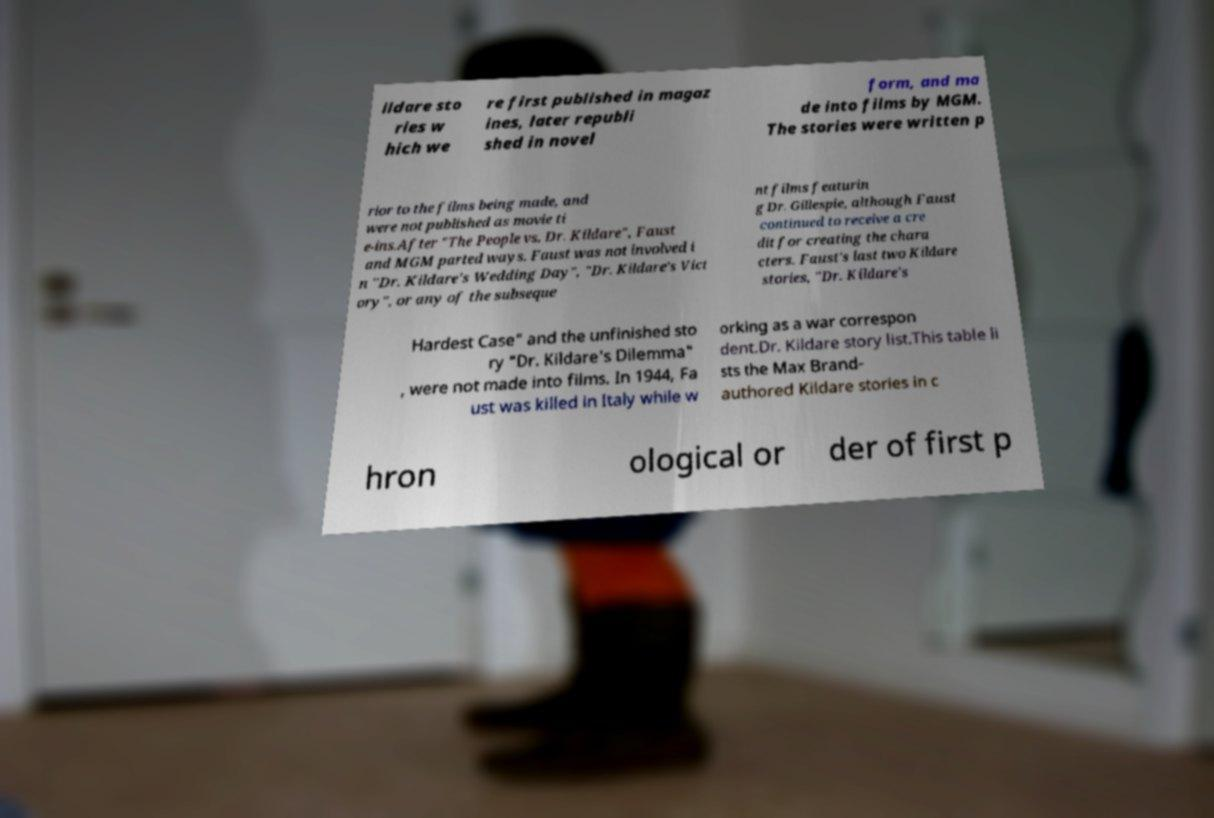Could you assist in decoding the text presented in this image and type it out clearly? ildare sto ries w hich we re first published in magaz ines, later republi shed in novel form, and ma de into films by MGM. The stories were written p rior to the films being made, and were not published as movie ti e-ins.After "The People vs. Dr. Kildare", Faust and MGM parted ways. Faust was not involved i n "Dr. Kildare's Wedding Day", "Dr. Kildare's Vict ory", or any of the subseque nt films featurin g Dr. Gillespie, although Faust continued to receive a cre dit for creating the chara cters. Faust's last two Kildare stories, "Dr. Kildare's Hardest Case" and the unfinished sto ry "Dr. Kildare's Dilemma" , were not made into films. In 1944, Fa ust was killed in Italy while w orking as a war correspon dent.Dr. Kildare story list.This table li sts the Max Brand- authored Kildare stories in c hron ological or der of first p 